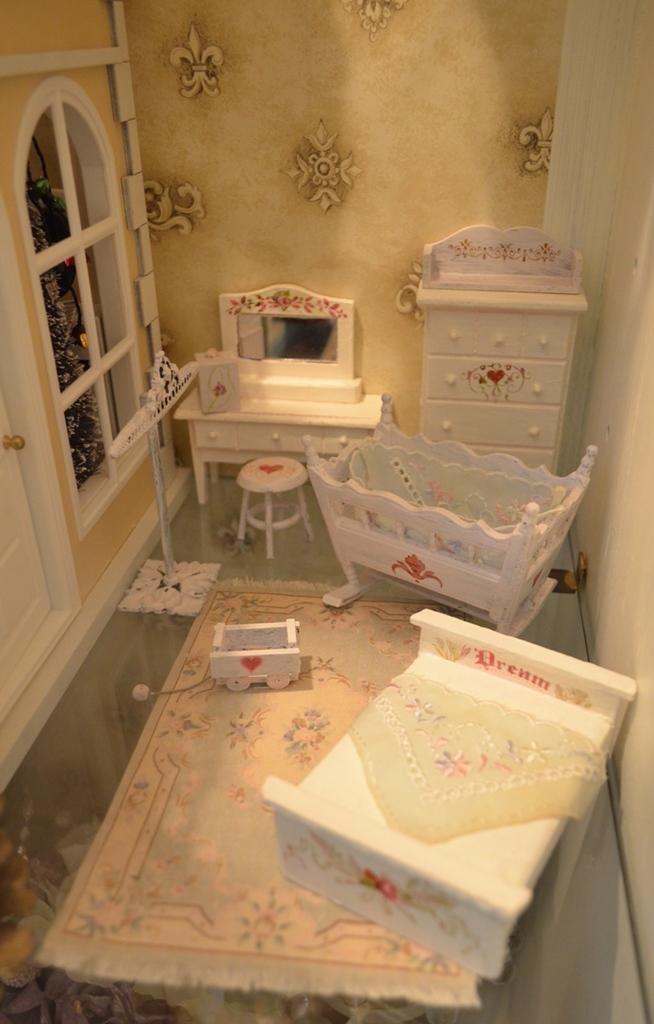Describe this image in one or two sentences. This is the picture inside the room. There is a bed in the middle, at the back there is a cupboard and there is a mirror on the table and there is a stool, at the left there is a door and window and at the bottom there is a mat. 